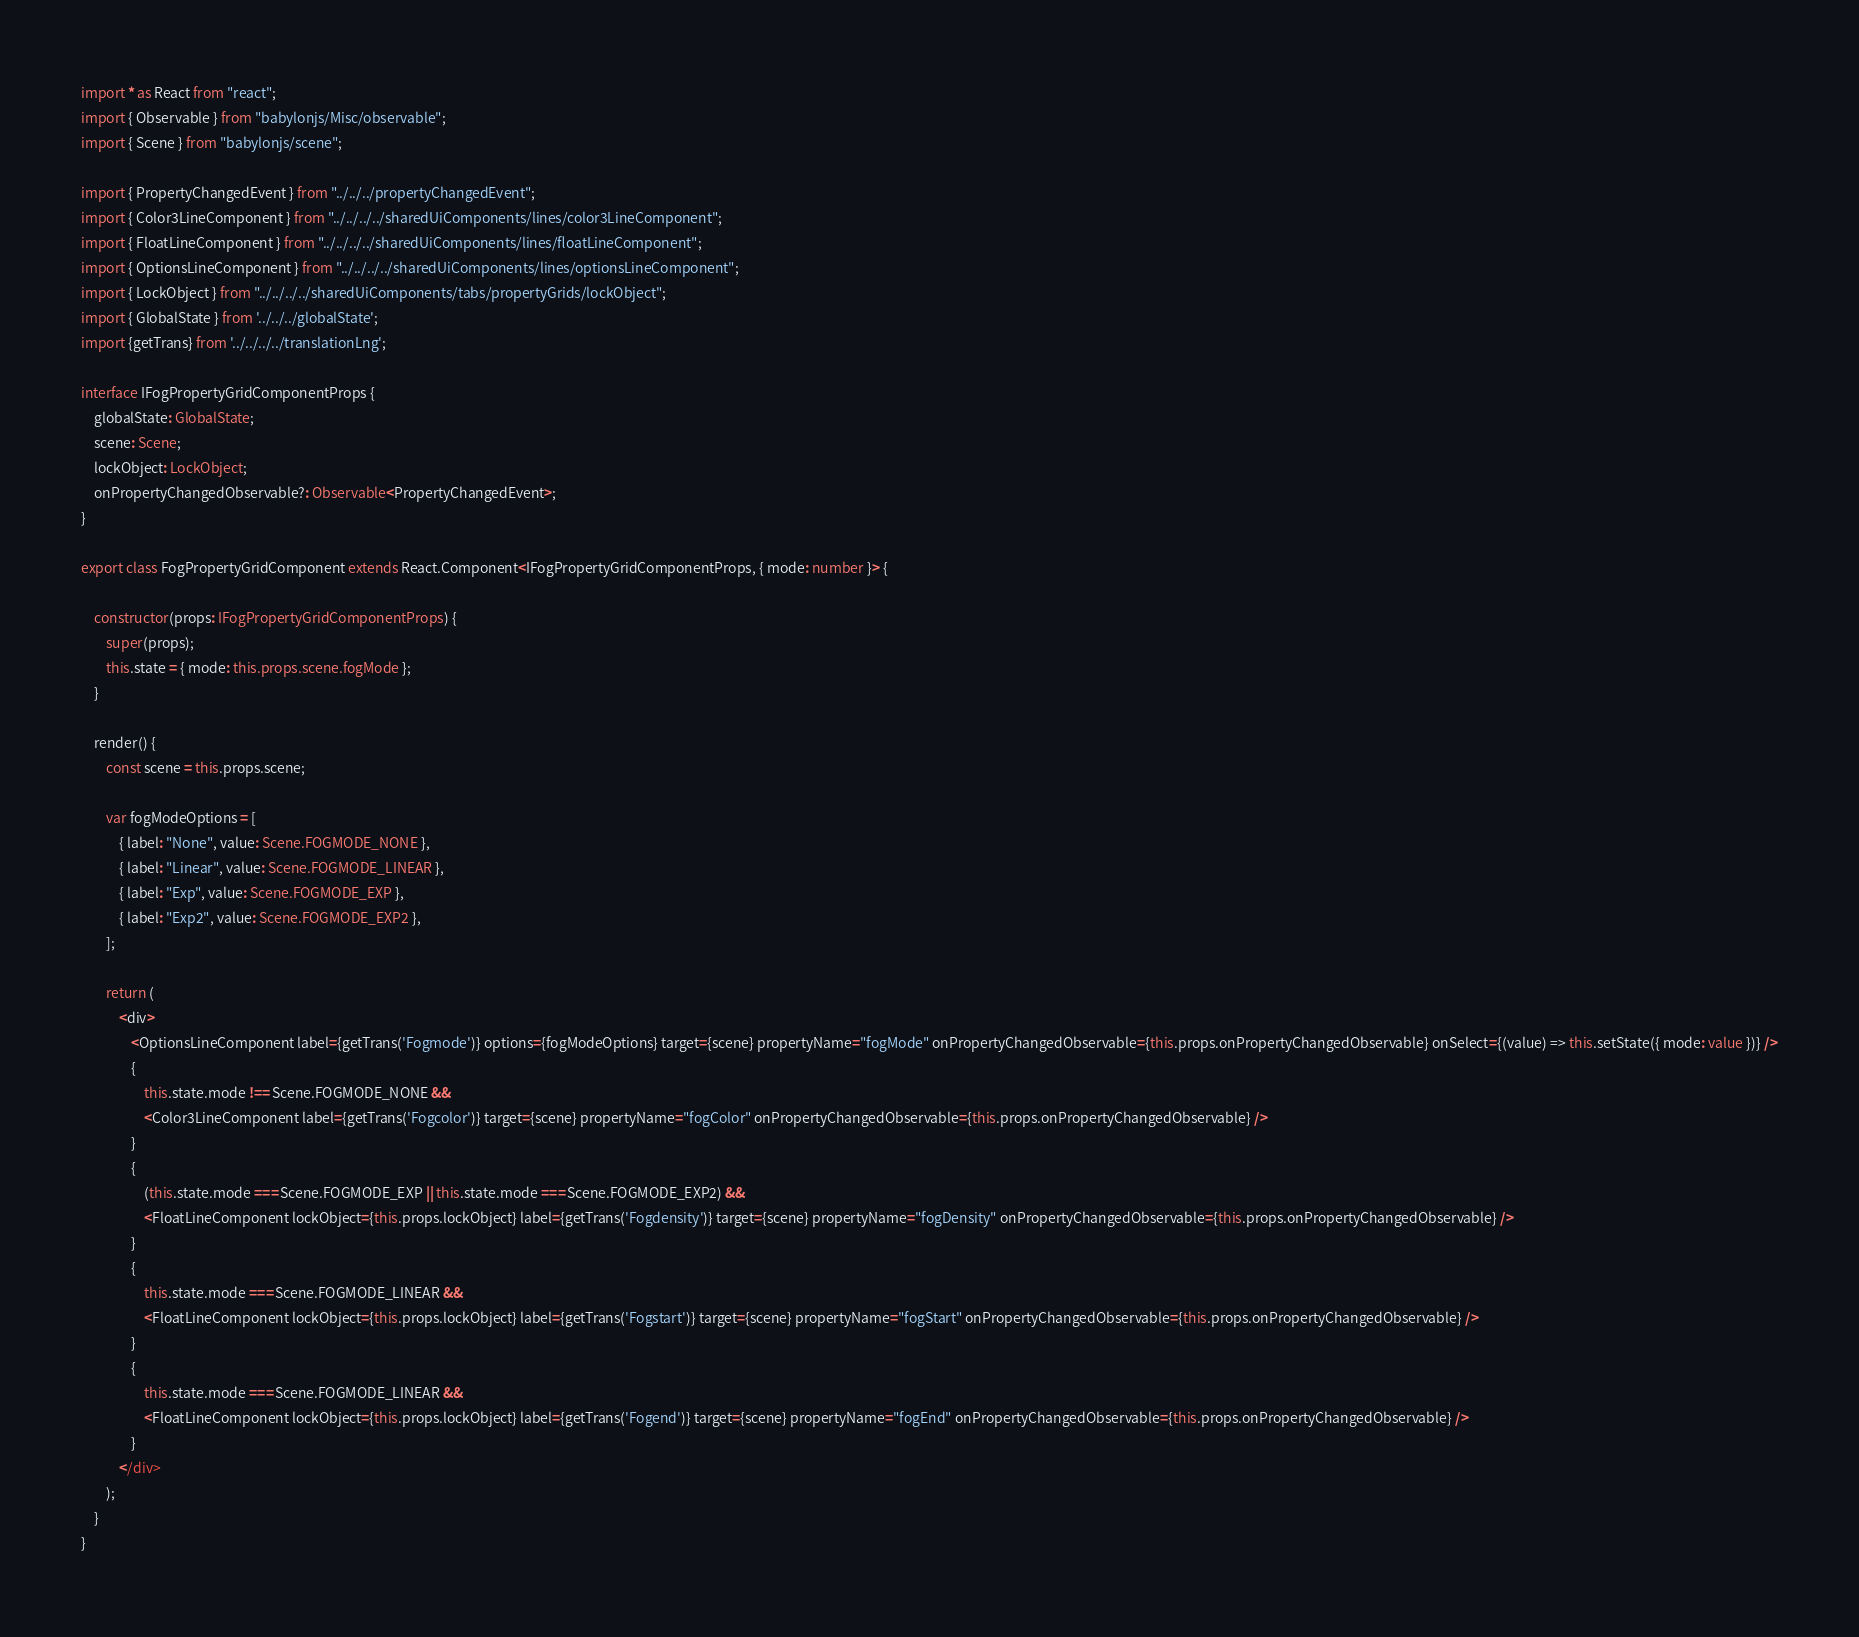Convert code to text. <code><loc_0><loc_0><loc_500><loc_500><_TypeScript_>import * as React from "react";
import { Observable } from "babylonjs/Misc/observable";
import { Scene } from "babylonjs/scene";

import { PropertyChangedEvent } from "../../../propertyChangedEvent";
import { Color3LineComponent } from "../../../../sharedUiComponents/lines/color3LineComponent";
import { FloatLineComponent } from "../../../../sharedUiComponents/lines/floatLineComponent";
import { OptionsLineComponent } from "../../../../sharedUiComponents/lines/optionsLineComponent";
import { LockObject } from "../../../../sharedUiComponents/tabs/propertyGrids/lockObject";
import { GlobalState } from '../../../globalState';
import {getTrans} from '../../../../translationLng';

interface IFogPropertyGridComponentProps {
    globalState: GlobalState;
    scene: Scene;
    lockObject: LockObject;
    onPropertyChangedObservable?: Observable<PropertyChangedEvent>;
}

export class FogPropertyGridComponent extends React.Component<IFogPropertyGridComponentProps, { mode: number }> {

    constructor(props: IFogPropertyGridComponentProps) {
        super(props);
        this.state = { mode: this.props.scene.fogMode };
    }

    render() {
        const scene = this.props.scene;

        var fogModeOptions = [
            { label: "None", value: Scene.FOGMODE_NONE },
            { label: "Linear", value: Scene.FOGMODE_LINEAR },
            { label: "Exp", value: Scene.FOGMODE_EXP },
            { label: "Exp2", value: Scene.FOGMODE_EXP2 },
        ];

        return (
            <div>
                <OptionsLineComponent label={getTrans('Fogmode')} options={fogModeOptions} target={scene} propertyName="fogMode" onPropertyChangedObservable={this.props.onPropertyChangedObservable} onSelect={(value) => this.setState({ mode: value })} />
                {
                    this.state.mode !== Scene.FOGMODE_NONE &&
                    <Color3LineComponent label={getTrans('Fogcolor')} target={scene} propertyName="fogColor" onPropertyChangedObservable={this.props.onPropertyChangedObservable} />
                }
                {
                    (this.state.mode === Scene.FOGMODE_EXP || this.state.mode === Scene.FOGMODE_EXP2) &&
                    <FloatLineComponent lockObject={this.props.lockObject} label={getTrans('Fogdensity')} target={scene} propertyName="fogDensity" onPropertyChangedObservable={this.props.onPropertyChangedObservable} />
                }
                {
                    this.state.mode === Scene.FOGMODE_LINEAR &&
                    <FloatLineComponent lockObject={this.props.lockObject} label={getTrans('Fogstart')} target={scene} propertyName="fogStart" onPropertyChangedObservable={this.props.onPropertyChangedObservable} />
                }
                {
                    this.state.mode === Scene.FOGMODE_LINEAR &&
                    <FloatLineComponent lockObject={this.props.lockObject} label={getTrans('Fogend')} target={scene} propertyName="fogEnd" onPropertyChangedObservable={this.props.onPropertyChangedObservable} />
                }
            </div>
        );
    }
}</code> 